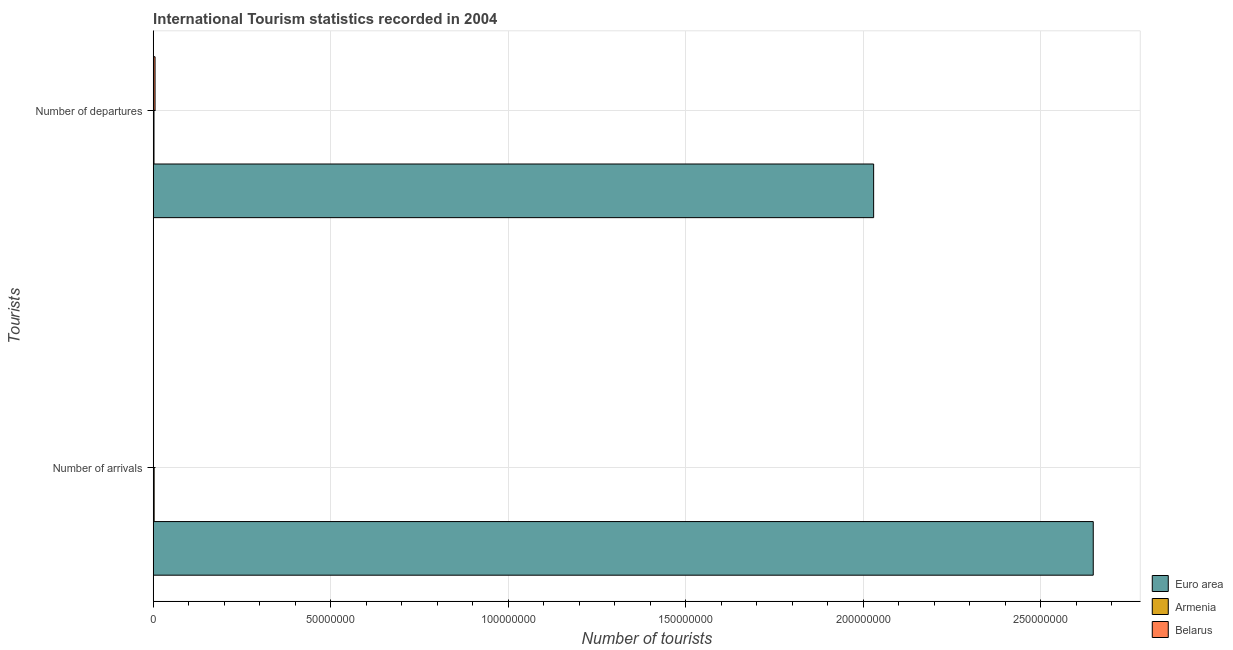How many different coloured bars are there?
Your answer should be very brief. 3. How many groups of bars are there?
Your answer should be very brief. 2. How many bars are there on the 2nd tick from the bottom?
Give a very brief answer. 3. What is the label of the 1st group of bars from the top?
Keep it short and to the point. Number of departures. What is the number of tourist departures in Armenia?
Make the answer very short. 2.21e+05. Across all countries, what is the maximum number of tourist departures?
Give a very brief answer. 2.03e+08. Across all countries, what is the minimum number of tourist arrivals?
Provide a short and direct response. 6.80e+04. In which country was the number of tourist arrivals minimum?
Make the answer very short. Belarus. What is the total number of tourist arrivals in the graph?
Your answer should be very brief. 2.65e+08. What is the difference between the number of tourist departures in Armenia and that in Euro area?
Provide a succinct answer. -2.03e+08. What is the difference between the number of tourist departures in Belarus and the number of tourist arrivals in Euro area?
Give a very brief answer. -2.64e+08. What is the average number of tourist departures per country?
Your response must be concise. 6.79e+07. What is the difference between the number of tourist departures and number of tourist arrivals in Euro area?
Your response must be concise. -6.19e+07. In how many countries, is the number of tourist arrivals greater than 180000000 ?
Offer a terse response. 1. What is the ratio of the number of tourist departures in Euro area to that in Armenia?
Make the answer very short. 918.23. What does the 2nd bar from the top in Number of departures represents?
Provide a succinct answer. Armenia. What does the 2nd bar from the bottom in Number of departures represents?
Make the answer very short. Armenia. Are all the bars in the graph horizontal?
Your response must be concise. Yes. What is the difference between two consecutive major ticks on the X-axis?
Your answer should be compact. 5.00e+07. Are the values on the major ticks of X-axis written in scientific E-notation?
Make the answer very short. No. Does the graph contain any zero values?
Ensure brevity in your answer.  No. Does the graph contain grids?
Ensure brevity in your answer.  Yes. Where does the legend appear in the graph?
Your response must be concise. Bottom right. What is the title of the graph?
Ensure brevity in your answer.  International Tourism statistics recorded in 2004. What is the label or title of the X-axis?
Keep it short and to the point. Number of tourists. What is the label or title of the Y-axis?
Keep it short and to the point. Tourists. What is the Number of tourists in Euro area in Number of arrivals?
Offer a terse response. 2.65e+08. What is the Number of tourists in Armenia in Number of arrivals?
Ensure brevity in your answer.  2.63e+05. What is the Number of tourists of Belarus in Number of arrivals?
Ensure brevity in your answer.  6.80e+04. What is the Number of tourists in Euro area in Number of departures?
Keep it short and to the point. 2.03e+08. What is the Number of tourists of Armenia in Number of departures?
Your response must be concise. 2.21e+05. What is the Number of tourists in Belarus in Number of departures?
Offer a terse response. 5.15e+05. Across all Tourists, what is the maximum Number of tourists in Euro area?
Ensure brevity in your answer.  2.65e+08. Across all Tourists, what is the maximum Number of tourists in Armenia?
Provide a succinct answer. 2.63e+05. Across all Tourists, what is the maximum Number of tourists in Belarus?
Your answer should be very brief. 5.15e+05. Across all Tourists, what is the minimum Number of tourists of Euro area?
Offer a very short reply. 2.03e+08. Across all Tourists, what is the minimum Number of tourists of Armenia?
Your response must be concise. 2.21e+05. Across all Tourists, what is the minimum Number of tourists of Belarus?
Give a very brief answer. 6.80e+04. What is the total Number of tourists of Euro area in the graph?
Your response must be concise. 4.68e+08. What is the total Number of tourists in Armenia in the graph?
Your answer should be very brief. 4.84e+05. What is the total Number of tourists in Belarus in the graph?
Give a very brief answer. 5.83e+05. What is the difference between the Number of tourists in Euro area in Number of arrivals and that in Number of departures?
Provide a short and direct response. 6.19e+07. What is the difference between the Number of tourists in Armenia in Number of arrivals and that in Number of departures?
Provide a short and direct response. 4.20e+04. What is the difference between the Number of tourists in Belarus in Number of arrivals and that in Number of departures?
Give a very brief answer. -4.47e+05. What is the difference between the Number of tourists in Euro area in Number of arrivals and the Number of tourists in Armenia in Number of departures?
Give a very brief answer. 2.65e+08. What is the difference between the Number of tourists in Euro area in Number of arrivals and the Number of tourists in Belarus in Number of departures?
Provide a succinct answer. 2.64e+08. What is the difference between the Number of tourists in Armenia in Number of arrivals and the Number of tourists in Belarus in Number of departures?
Your answer should be compact. -2.52e+05. What is the average Number of tourists in Euro area per Tourists?
Your answer should be compact. 2.34e+08. What is the average Number of tourists of Armenia per Tourists?
Your answer should be compact. 2.42e+05. What is the average Number of tourists in Belarus per Tourists?
Offer a terse response. 2.92e+05. What is the difference between the Number of tourists in Euro area and Number of tourists in Armenia in Number of arrivals?
Your answer should be very brief. 2.65e+08. What is the difference between the Number of tourists of Euro area and Number of tourists of Belarus in Number of arrivals?
Make the answer very short. 2.65e+08. What is the difference between the Number of tourists of Armenia and Number of tourists of Belarus in Number of arrivals?
Provide a short and direct response. 1.95e+05. What is the difference between the Number of tourists of Euro area and Number of tourists of Armenia in Number of departures?
Provide a short and direct response. 2.03e+08. What is the difference between the Number of tourists in Euro area and Number of tourists in Belarus in Number of departures?
Provide a succinct answer. 2.02e+08. What is the difference between the Number of tourists of Armenia and Number of tourists of Belarus in Number of departures?
Offer a very short reply. -2.94e+05. What is the ratio of the Number of tourists in Euro area in Number of arrivals to that in Number of departures?
Ensure brevity in your answer.  1.3. What is the ratio of the Number of tourists in Armenia in Number of arrivals to that in Number of departures?
Your answer should be very brief. 1.19. What is the ratio of the Number of tourists in Belarus in Number of arrivals to that in Number of departures?
Make the answer very short. 0.13. What is the difference between the highest and the second highest Number of tourists of Euro area?
Your answer should be compact. 6.19e+07. What is the difference between the highest and the second highest Number of tourists in Armenia?
Offer a terse response. 4.20e+04. What is the difference between the highest and the second highest Number of tourists of Belarus?
Your response must be concise. 4.47e+05. What is the difference between the highest and the lowest Number of tourists of Euro area?
Your answer should be compact. 6.19e+07. What is the difference between the highest and the lowest Number of tourists of Armenia?
Your answer should be compact. 4.20e+04. What is the difference between the highest and the lowest Number of tourists of Belarus?
Offer a terse response. 4.47e+05. 